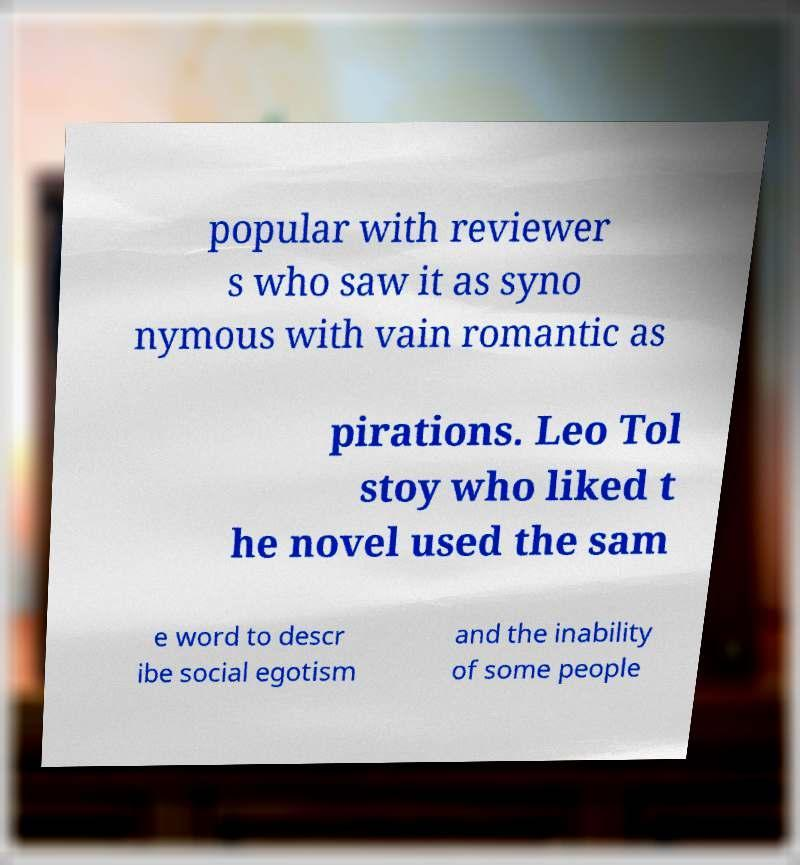For documentation purposes, I need the text within this image transcribed. Could you provide that? popular with reviewer s who saw it as syno nymous with vain romantic as pirations. Leo Tol stoy who liked t he novel used the sam e word to descr ibe social egotism and the inability of some people 